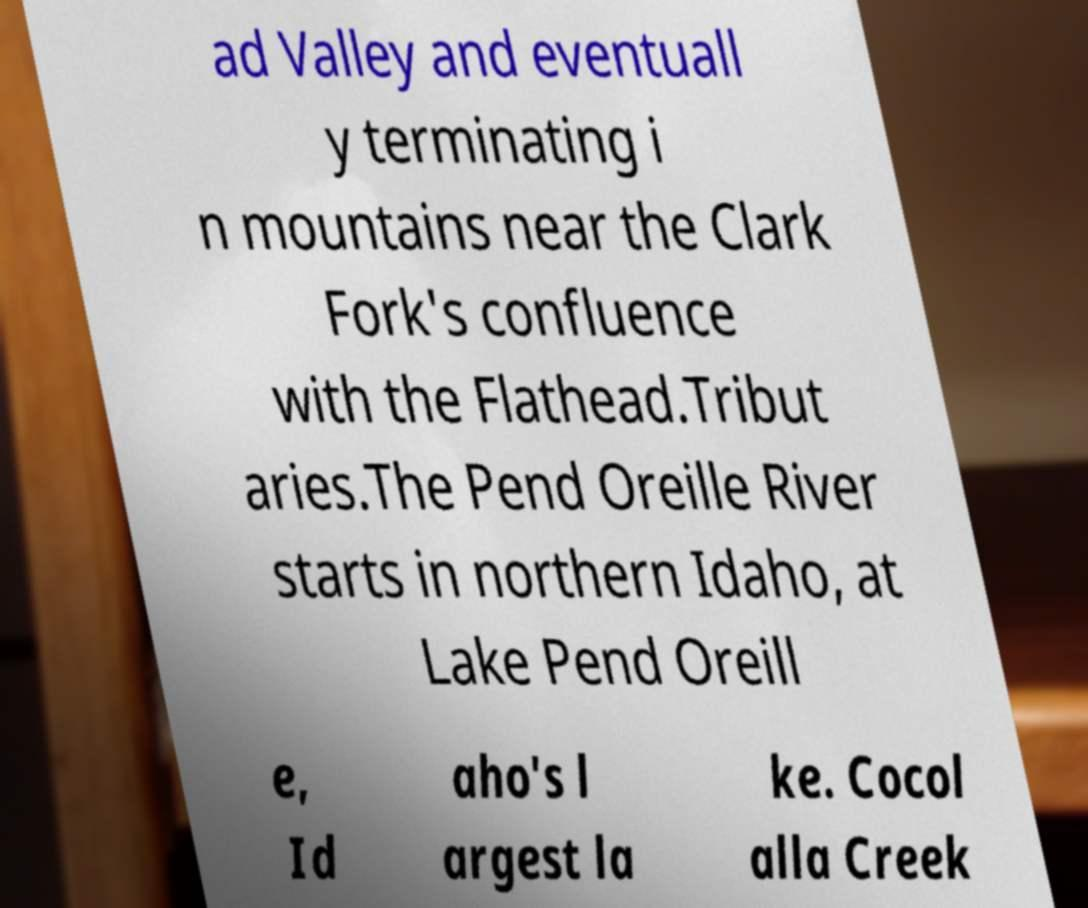What messages or text are displayed in this image? I need them in a readable, typed format. ad Valley and eventuall y terminating i n mountains near the Clark Fork's confluence with the Flathead.Tribut aries.The Pend Oreille River starts in northern Idaho, at Lake Pend Oreill e, Id aho's l argest la ke. Cocol alla Creek 